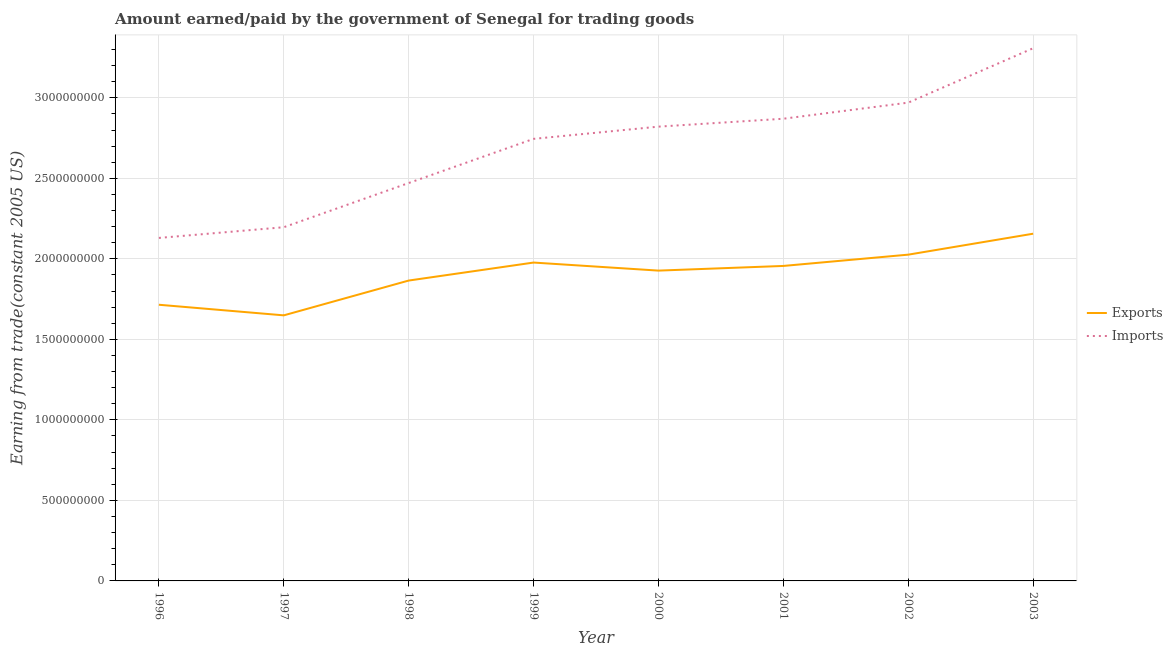Does the line corresponding to amount earned from exports intersect with the line corresponding to amount paid for imports?
Ensure brevity in your answer.  No. Is the number of lines equal to the number of legend labels?
Provide a succinct answer. Yes. What is the amount paid for imports in 1997?
Give a very brief answer. 2.20e+09. Across all years, what is the maximum amount earned from exports?
Offer a very short reply. 2.16e+09. Across all years, what is the minimum amount earned from exports?
Provide a short and direct response. 1.65e+09. In which year was the amount paid for imports maximum?
Provide a succinct answer. 2003. In which year was the amount earned from exports minimum?
Offer a very short reply. 1997. What is the total amount paid for imports in the graph?
Your answer should be compact. 2.15e+1. What is the difference between the amount earned from exports in 1998 and that in 1999?
Provide a short and direct response. -1.12e+08. What is the difference between the amount earned from exports in 2003 and the amount paid for imports in 1996?
Your response must be concise. 2.62e+07. What is the average amount paid for imports per year?
Give a very brief answer. 2.69e+09. In the year 1998, what is the difference between the amount earned from exports and amount paid for imports?
Make the answer very short. -6.06e+08. What is the ratio of the amount paid for imports in 2001 to that in 2002?
Make the answer very short. 0.97. Is the difference between the amount paid for imports in 1999 and 2003 greater than the difference between the amount earned from exports in 1999 and 2003?
Provide a succinct answer. No. What is the difference between the highest and the second highest amount paid for imports?
Offer a very short reply. 3.38e+08. What is the difference between the highest and the lowest amount earned from exports?
Ensure brevity in your answer.  5.07e+08. In how many years, is the amount paid for imports greater than the average amount paid for imports taken over all years?
Your answer should be compact. 5. Is the sum of the amount paid for imports in 1999 and 2002 greater than the maximum amount earned from exports across all years?
Make the answer very short. Yes. Does the amount paid for imports monotonically increase over the years?
Provide a short and direct response. Yes. Is the amount earned from exports strictly less than the amount paid for imports over the years?
Offer a terse response. Yes. How many lines are there?
Keep it short and to the point. 2. Does the graph contain any zero values?
Offer a terse response. No. Does the graph contain grids?
Your answer should be compact. Yes. Where does the legend appear in the graph?
Ensure brevity in your answer.  Center right. What is the title of the graph?
Provide a succinct answer. Amount earned/paid by the government of Senegal for trading goods. Does "Female labor force" appear as one of the legend labels in the graph?
Your answer should be compact. No. What is the label or title of the X-axis?
Your answer should be very brief. Year. What is the label or title of the Y-axis?
Offer a terse response. Earning from trade(constant 2005 US). What is the Earning from trade(constant 2005 US) of Exports in 1996?
Provide a succinct answer. 1.72e+09. What is the Earning from trade(constant 2005 US) of Imports in 1996?
Your response must be concise. 2.13e+09. What is the Earning from trade(constant 2005 US) in Exports in 1997?
Ensure brevity in your answer.  1.65e+09. What is the Earning from trade(constant 2005 US) of Imports in 1997?
Your answer should be compact. 2.20e+09. What is the Earning from trade(constant 2005 US) in Exports in 1998?
Provide a succinct answer. 1.87e+09. What is the Earning from trade(constant 2005 US) of Imports in 1998?
Offer a very short reply. 2.47e+09. What is the Earning from trade(constant 2005 US) of Exports in 1999?
Provide a short and direct response. 1.98e+09. What is the Earning from trade(constant 2005 US) in Imports in 1999?
Keep it short and to the point. 2.75e+09. What is the Earning from trade(constant 2005 US) of Exports in 2000?
Provide a succinct answer. 1.93e+09. What is the Earning from trade(constant 2005 US) in Imports in 2000?
Ensure brevity in your answer.  2.82e+09. What is the Earning from trade(constant 2005 US) in Exports in 2001?
Provide a short and direct response. 1.96e+09. What is the Earning from trade(constant 2005 US) of Imports in 2001?
Make the answer very short. 2.87e+09. What is the Earning from trade(constant 2005 US) in Exports in 2002?
Your answer should be very brief. 2.03e+09. What is the Earning from trade(constant 2005 US) of Imports in 2002?
Provide a short and direct response. 2.97e+09. What is the Earning from trade(constant 2005 US) in Exports in 2003?
Your response must be concise. 2.16e+09. What is the Earning from trade(constant 2005 US) of Imports in 2003?
Provide a succinct answer. 3.31e+09. Across all years, what is the maximum Earning from trade(constant 2005 US) of Exports?
Keep it short and to the point. 2.16e+09. Across all years, what is the maximum Earning from trade(constant 2005 US) in Imports?
Ensure brevity in your answer.  3.31e+09. Across all years, what is the minimum Earning from trade(constant 2005 US) in Exports?
Your answer should be compact. 1.65e+09. Across all years, what is the minimum Earning from trade(constant 2005 US) of Imports?
Make the answer very short. 2.13e+09. What is the total Earning from trade(constant 2005 US) of Exports in the graph?
Make the answer very short. 1.53e+1. What is the total Earning from trade(constant 2005 US) in Imports in the graph?
Offer a very short reply. 2.15e+1. What is the difference between the Earning from trade(constant 2005 US) of Exports in 1996 and that in 1997?
Offer a terse response. 6.59e+07. What is the difference between the Earning from trade(constant 2005 US) of Imports in 1996 and that in 1997?
Your response must be concise. -6.64e+07. What is the difference between the Earning from trade(constant 2005 US) of Exports in 1996 and that in 1998?
Make the answer very short. -1.50e+08. What is the difference between the Earning from trade(constant 2005 US) of Imports in 1996 and that in 1998?
Make the answer very short. -3.41e+08. What is the difference between the Earning from trade(constant 2005 US) of Exports in 1996 and that in 1999?
Your answer should be very brief. -2.62e+08. What is the difference between the Earning from trade(constant 2005 US) of Imports in 1996 and that in 1999?
Offer a very short reply. -6.15e+08. What is the difference between the Earning from trade(constant 2005 US) of Exports in 1996 and that in 2000?
Provide a succinct answer. -2.12e+08. What is the difference between the Earning from trade(constant 2005 US) in Imports in 1996 and that in 2000?
Your answer should be very brief. -6.91e+08. What is the difference between the Earning from trade(constant 2005 US) of Exports in 1996 and that in 2001?
Your response must be concise. -2.41e+08. What is the difference between the Earning from trade(constant 2005 US) of Imports in 1996 and that in 2001?
Offer a terse response. -7.40e+08. What is the difference between the Earning from trade(constant 2005 US) of Exports in 1996 and that in 2002?
Provide a short and direct response. -3.11e+08. What is the difference between the Earning from trade(constant 2005 US) of Imports in 1996 and that in 2002?
Ensure brevity in your answer.  -8.40e+08. What is the difference between the Earning from trade(constant 2005 US) in Exports in 1996 and that in 2003?
Your answer should be compact. -4.41e+08. What is the difference between the Earning from trade(constant 2005 US) in Imports in 1996 and that in 2003?
Your answer should be very brief. -1.18e+09. What is the difference between the Earning from trade(constant 2005 US) of Exports in 1997 and that in 1998?
Provide a short and direct response. -2.16e+08. What is the difference between the Earning from trade(constant 2005 US) in Imports in 1997 and that in 1998?
Your answer should be compact. -2.74e+08. What is the difference between the Earning from trade(constant 2005 US) of Exports in 1997 and that in 1999?
Your answer should be very brief. -3.28e+08. What is the difference between the Earning from trade(constant 2005 US) of Imports in 1997 and that in 1999?
Provide a short and direct response. -5.49e+08. What is the difference between the Earning from trade(constant 2005 US) in Exports in 1997 and that in 2000?
Your answer should be compact. -2.78e+08. What is the difference between the Earning from trade(constant 2005 US) in Imports in 1997 and that in 2000?
Ensure brevity in your answer.  -6.25e+08. What is the difference between the Earning from trade(constant 2005 US) of Exports in 1997 and that in 2001?
Make the answer very short. -3.07e+08. What is the difference between the Earning from trade(constant 2005 US) in Imports in 1997 and that in 2001?
Ensure brevity in your answer.  -6.74e+08. What is the difference between the Earning from trade(constant 2005 US) in Exports in 1997 and that in 2002?
Your answer should be compact. -3.77e+08. What is the difference between the Earning from trade(constant 2005 US) of Imports in 1997 and that in 2002?
Provide a short and direct response. -7.74e+08. What is the difference between the Earning from trade(constant 2005 US) in Exports in 1997 and that in 2003?
Keep it short and to the point. -5.07e+08. What is the difference between the Earning from trade(constant 2005 US) in Imports in 1997 and that in 2003?
Your answer should be very brief. -1.11e+09. What is the difference between the Earning from trade(constant 2005 US) of Exports in 1998 and that in 1999?
Ensure brevity in your answer.  -1.12e+08. What is the difference between the Earning from trade(constant 2005 US) of Imports in 1998 and that in 1999?
Your answer should be compact. -2.74e+08. What is the difference between the Earning from trade(constant 2005 US) of Exports in 1998 and that in 2000?
Provide a succinct answer. -6.18e+07. What is the difference between the Earning from trade(constant 2005 US) in Imports in 1998 and that in 2000?
Your answer should be very brief. -3.50e+08. What is the difference between the Earning from trade(constant 2005 US) in Exports in 1998 and that in 2001?
Your answer should be compact. -9.08e+07. What is the difference between the Earning from trade(constant 2005 US) of Imports in 1998 and that in 2001?
Your response must be concise. -3.99e+08. What is the difference between the Earning from trade(constant 2005 US) in Exports in 1998 and that in 2002?
Your response must be concise. -1.61e+08. What is the difference between the Earning from trade(constant 2005 US) in Imports in 1998 and that in 2002?
Your answer should be compact. -4.99e+08. What is the difference between the Earning from trade(constant 2005 US) in Exports in 1998 and that in 2003?
Keep it short and to the point. -2.91e+08. What is the difference between the Earning from trade(constant 2005 US) in Imports in 1998 and that in 2003?
Make the answer very short. -8.37e+08. What is the difference between the Earning from trade(constant 2005 US) of Exports in 1999 and that in 2000?
Make the answer very short. 5.00e+07. What is the difference between the Earning from trade(constant 2005 US) in Imports in 1999 and that in 2000?
Your response must be concise. -7.59e+07. What is the difference between the Earning from trade(constant 2005 US) of Exports in 1999 and that in 2001?
Your response must be concise. 2.10e+07. What is the difference between the Earning from trade(constant 2005 US) in Imports in 1999 and that in 2001?
Keep it short and to the point. -1.25e+08. What is the difference between the Earning from trade(constant 2005 US) of Exports in 1999 and that in 2002?
Ensure brevity in your answer.  -4.91e+07. What is the difference between the Earning from trade(constant 2005 US) in Imports in 1999 and that in 2002?
Offer a very short reply. -2.25e+08. What is the difference between the Earning from trade(constant 2005 US) in Exports in 1999 and that in 2003?
Your response must be concise. -1.79e+08. What is the difference between the Earning from trade(constant 2005 US) in Imports in 1999 and that in 2003?
Give a very brief answer. -5.63e+08. What is the difference between the Earning from trade(constant 2005 US) in Exports in 2000 and that in 2001?
Your response must be concise. -2.90e+07. What is the difference between the Earning from trade(constant 2005 US) in Imports in 2000 and that in 2001?
Make the answer very short. -4.91e+07. What is the difference between the Earning from trade(constant 2005 US) in Exports in 2000 and that in 2002?
Provide a short and direct response. -9.91e+07. What is the difference between the Earning from trade(constant 2005 US) in Imports in 2000 and that in 2002?
Provide a succinct answer. -1.49e+08. What is the difference between the Earning from trade(constant 2005 US) of Exports in 2000 and that in 2003?
Your response must be concise. -2.29e+08. What is the difference between the Earning from trade(constant 2005 US) of Imports in 2000 and that in 2003?
Your answer should be very brief. -4.87e+08. What is the difference between the Earning from trade(constant 2005 US) of Exports in 2001 and that in 2002?
Keep it short and to the point. -7.01e+07. What is the difference between the Earning from trade(constant 2005 US) in Imports in 2001 and that in 2002?
Provide a succinct answer. -1.00e+08. What is the difference between the Earning from trade(constant 2005 US) in Exports in 2001 and that in 2003?
Your answer should be very brief. -2.00e+08. What is the difference between the Earning from trade(constant 2005 US) in Imports in 2001 and that in 2003?
Your answer should be compact. -4.38e+08. What is the difference between the Earning from trade(constant 2005 US) in Exports in 2002 and that in 2003?
Your answer should be compact. -1.30e+08. What is the difference between the Earning from trade(constant 2005 US) of Imports in 2002 and that in 2003?
Your response must be concise. -3.38e+08. What is the difference between the Earning from trade(constant 2005 US) in Exports in 1996 and the Earning from trade(constant 2005 US) in Imports in 1997?
Give a very brief answer. -4.81e+08. What is the difference between the Earning from trade(constant 2005 US) in Exports in 1996 and the Earning from trade(constant 2005 US) in Imports in 1998?
Give a very brief answer. -7.56e+08. What is the difference between the Earning from trade(constant 2005 US) in Exports in 1996 and the Earning from trade(constant 2005 US) in Imports in 1999?
Offer a terse response. -1.03e+09. What is the difference between the Earning from trade(constant 2005 US) of Exports in 1996 and the Earning from trade(constant 2005 US) of Imports in 2000?
Give a very brief answer. -1.11e+09. What is the difference between the Earning from trade(constant 2005 US) of Exports in 1996 and the Earning from trade(constant 2005 US) of Imports in 2001?
Offer a very short reply. -1.16e+09. What is the difference between the Earning from trade(constant 2005 US) of Exports in 1996 and the Earning from trade(constant 2005 US) of Imports in 2002?
Your answer should be compact. -1.26e+09. What is the difference between the Earning from trade(constant 2005 US) in Exports in 1996 and the Earning from trade(constant 2005 US) in Imports in 2003?
Your response must be concise. -1.59e+09. What is the difference between the Earning from trade(constant 2005 US) in Exports in 1997 and the Earning from trade(constant 2005 US) in Imports in 1998?
Your answer should be very brief. -8.22e+08. What is the difference between the Earning from trade(constant 2005 US) of Exports in 1997 and the Earning from trade(constant 2005 US) of Imports in 1999?
Your response must be concise. -1.10e+09. What is the difference between the Earning from trade(constant 2005 US) in Exports in 1997 and the Earning from trade(constant 2005 US) in Imports in 2000?
Provide a short and direct response. -1.17e+09. What is the difference between the Earning from trade(constant 2005 US) of Exports in 1997 and the Earning from trade(constant 2005 US) of Imports in 2001?
Give a very brief answer. -1.22e+09. What is the difference between the Earning from trade(constant 2005 US) of Exports in 1997 and the Earning from trade(constant 2005 US) of Imports in 2002?
Offer a terse response. -1.32e+09. What is the difference between the Earning from trade(constant 2005 US) of Exports in 1997 and the Earning from trade(constant 2005 US) of Imports in 2003?
Keep it short and to the point. -1.66e+09. What is the difference between the Earning from trade(constant 2005 US) in Exports in 1998 and the Earning from trade(constant 2005 US) in Imports in 1999?
Keep it short and to the point. -8.80e+08. What is the difference between the Earning from trade(constant 2005 US) in Exports in 1998 and the Earning from trade(constant 2005 US) in Imports in 2000?
Your response must be concise. -9.56e+08. What is the difference between the Earning from trade(constant 2005 US) in Exports in 1998 and the Earning from trade(constant 2005 US) in Imports in 2001?
Ensure brevity in your answer.  -1.00e+09. What is the difference between the Earning from trade(constant 2005 US) in Exports in 1998 and the Earning from trade(constant 2005 US) in Imports in 2002?
Give a very brief answer. -1.10e+09. What is the difference between the Earning from trade(constant 2005 US) of Exports in 1998 and the Earning from trade(constant 2005 US) of Imports in 2003?
Provide a succinct answer. -1.44e+09. What is the difference between the Earning from trade(constant 2005 US) in Exports in 1999 and the Earning from trade(constant 2005 US) in Imports in 2000?
Your answer should be compact. -8.44e+08. What is the difference between the Earning from trade(constant 2005 US) in Exports in 1999 and the Earning from trade(constant 2005 US) in Imports in 2001?
Offer a terse response. -8.93e+08. What is the difference between the Earning from trade(constant 2005 US) in Exports in 1999 and the Earning from trade(constant 2005 US) in Imports in 2002?
Your response must be concise. -9.93e+08. What is the difference between the Earning from trade(constant 2005 US) in Exports in 1999 and the Earning from trade(constant 2005 US) in Imports in 2003?
Offer a very short reply. -1.33e+09. What is the difference between the Earning from trade(constant 2005 US) in Exports in 2000 and the Earning from trade(constant 2005 US) in Imports in 2001?
Make the answer very short. -9.43e+08. What is the difference between the Earning from trade(constant 2005 US) in Exports in 2000 and the Earning from trade(constant 2005 US) in Imports in 2002?
Provide a succinct answer. -1.04e+09. What is the difference between the Earning from trade(constant 2005 US) of Exports in 2000 and the Earning from trade(constant 2005 US) of Imports in 2003?
Offer a very short reply. -1.38e+09. What is the difference between the Earning from trade(constant 2005 US) of Exports in 2001 and the Earning from trade(constant 2005 US) of Imports in 2002?
Your answer should be very brief. -1.01e+09. What is the difference between the Earning from trade(constant 2005 US) of Exports in 2001 and the Earning from trade(constant 2005 US) of Imports in 2003?
Your answer should be compact. -1.35e+09. What is the difference between the Earning from trade(constant 2005 US) in Exports in 2002 and the Earning from trade(constant 2005 US) in Imports in 2003?
Make the answer very short. -1.28e+09. What is the average Earning from trade(constant 2005 US) of Exports per year?
Provide a succinct answer. 1.91e+09. What is the average Earning from trade(constant 2005 US) in Imports per year?
Your answer should be compact. 2.69e+09. In the year 1996, what is the difference between the Earning from trade(constant 2005 US) in Exports and Earning from trade(constant 2005 US) in Imports?
Give a very brief answer. -4.15e+08. In the year 1997, what is the difference between the Earning from trade(constant 2005 US) of Exports and Earning from trade(constant 2005 US) of Imports?
Provide a succinct answer. -5.47e+08. In the year 1998, what is the difference between the Earning from trade(constant 2005 US) of Exports and Earning from trade(constant 2005 US) of Imports?
Your response must be concise. -6.06e+08. In the year 1999, what is the difference between the Earning from trade(constant 2005 US) of Exports and Earning from trade(constant 2005 US) of Imports?
Offer a very short reply. -7.68e+08. In the year 2000, what is the difference between the Earning from trade(constant 2005 US) in Exports and Earning from trade(constant 2005 US) in Imports?
Your response must be concise. -8.94e+08. In the year 2001, what is the difference between the Earning from trade(constant 2005 US) of Exports and Earning from trade(constant 2005 US) of Imports?
Your answer should be very brief. -9.14e+08. In the year 2002, what is the difference between the Earning from trade(constant 2005 US) in Exports and Earning from trade(constant 2005 US) in Imports?
Offer a very short reply. -9.44e+08. In the year 2003, what is the difference between the Earning from trade(constant 2005 US) of Exports and Earning from trade(constant 2005 US) of Imports?
Your answer should be very brief. -1.15e+09. What is the ratio of the Earning from trade(constant 2005 US) in Exports in 1996 to that in 1997?
Provide a succinct answer. 1.04. What is the ratio of the Earning from trade(constant 2005 US) of Imports in 1996 to that in 1997?
Your answer should be compact. 0.97. What is the ratio of the Earning from trade(constant 2005 US) of Exports in 1996 to that in 1998?
Make the answer very short. 0.92. What is the ratio of the Earning from trade(constant 2005 US) in Imports in 1996 to that in 1998?
Your answer should be very brief. 0.86. What is the ratio of the Earning from trade(constant 2005 US) in Exports in 1996 to that in 1999?
Ensure brevity in your answer.  0.87. What is the ratio of the Earning from trade(constant 2005 US) in Imports in 1996 to that in 1999?
Make the answer very short. 0.78. What is the ratio of the Earning from trade(constant 2005 US) in Exports in 1996 to that in 2000?
Make the answer very short. 0.89. What is the ratio of the Earning from trade(constant 2005 US) in Imports in 1996 to that in 2000?
Offer a terse response. 0.76. What is the ratio of the Earning from trade(constant 2005 US) of Exports in 1996 to that in 2001?
Your response must be concise. 0.88. What is the ratio of the Earning from trade(constant 2005 US) of Imports in 1996 to that in 2001?
Provide a short and direct response. 0.74. What is the ratio of the Earning from trade(constant 2005 US) of Exports in 1996 to that in 2002?
Ensure brevity in your answer.  0.85. What is the ratio of the Earning from trade(constant 2005 US) in Imports in 1996 to that in 2002?
Keep it short and to the point. 0.72. What is the ratio of the Earning from trade(constant 2005 US) in Exports in 1996 to that in 2003?
Provide a succinct answer. 0.8. What is the ratio of the Earning from trade(constant 2005 US) of Imports in 1996 to that in 2003?
Your answer should be very brief. 0.64. What is the ratio of the Earning from trade(constant 2005 US) of Exports in 1997 to that in 1998?
Give a very brief answer. 0.88. What is the ratio of the Earning from trade(constant 2005 US) of Exports in 1997 to that in 1999?
Provide a short and direct response. 0.83. What is the ratio of the Earning from trade(constant 2005 US) in Imports in 1997 to that in 1999?
Give a very brief answer. 0.8. What is the ratio of the Earning from trade(constant 2005 US) in Exports in 1997 to that in 2000?
Your answer should be very brief. 0.86. What is the ratio of the Earning from trade(constant 2005 US) of Imports in 1997 to that in 2000?
Keep it short and to the point. 0.78. What is the ratio of the Earning from trade(constant 2005 US) in Exports in 1997 to that in 2001?
Give a very brief answer. 0.84. What is the ratio of the Earning from trade(constant 2005 US) in Imports in 1997 to that in 2001?
Ensure brevity in your answer.  0.77. What is the ratio of the Earning from trade(constant 2005 US) of Exports in 1997 to that in 2002?
Your response must be concise. 0.81. What is the ratio of the Earning from trade(constant 2005 US) in Imports in 1997 to that in 2002?
Keep it short and to the point. 0.74. What is the ratio of the Earning from trade(constant 2005 US) in Exports in 1997 to that in 2003?
Your answer should be compact. 0.76. What is the ratio of the Earning from trade(constant 2005 US) of Imports in 1997 to that in 2003?
Keep it short and to the point. 0.66. What is the ratio of the Earning from trade(constant 2005 US) in Exports in 1998 to that in 1999?
Make the answer very short. 0.94. What is the ratio of the Earning from trade(constant 2005 US) of Imports in 1998 to that in 1999?
Provide a short and direct response. 0.9. What is the ratio of the Earning from trade(constant 2005 US) of Exports in 1998 to that in 2000?
Your answer should be compact. 0.97. What is the ratio of the Earning from trade(constant 2005 US) in Imports in 1998 to that in 2000?
Make the answer very short. 0.88. What is the ratio of the Earning from trade(constant 2005 US) of Exports in 1998 to that in 2001?
Offer a very short reply. 0.95. What is the ratio of the Earning from trade(constant 2005 US) in Imports in 1998 to that in 2001?
Give a very brief answer. 0.86. What is the ratio of the Earning from trade(constant 2005 US) in Exports in 1998 to that in 2002?
Ensure brevity in your answer.  0.92. What is the ratio of the Earning from trade(constant 2005 US) of Imports in 1998 to that in 2002?
Offer a terse response. 0.83. What is the ratio of the Earning from trade(constant 2005 US) of Exports in 1998 to that in 2003?
Your answer should be compact. 0.87. What is the ratio of the Earning from trade(constant 2005 US) in Imports in 1998 to that in 2003?
Make the answer very short. 0.75. What is the ratio of the Earning from trade(constant 2005 US) of Exports in 1999 to that in 2000?
Keep it short and to the point. 1.03. What is the ratio of the Earning from trade(constant 2005 US) in Imports in 1999 to that in 2000?
Give a very brief answer. 0.97. What is the ratio of the Earning from trade(constant 2005 US) in Exports in 1999 to that in 2001?
Your answer should be very brief. 1.01. What is the ratio of the Earning from trade(constant 2005 US) in Imports in 1999 to that in 2001?
Keep it short and to the point. 0.96. What is the ratio of the Earning from trade(constant 2005 US) of Exports in 1999 to that in 2002?
Provide a short and direct response. 0.98. What is the ratio of the Earning from trade(constant 2005 US) of Imports in 1999 to that in 2002?
Provide a succinct answer. 0.92. What is the ratio of the Earning from trade(constant 2005 US) of Exports in 1999 to that in 2003?
Keep it short and to the point. 0.92. What is the ratio of the Earning from trade(constant 2005 US) of Imports in 1999 to that in 2003?
Your answer should be compact. 0.83. What is the ratio of the Earning from trade(constant 2005 US) in Exports in 2000 to that in 2001?
Ensure brevity in your answer.  0.99. What is the ratio of the Earning from trade(constant 2005 US) in Imports in 2000 to that in 2001?
Provide a succinct answer. 0.98. What is the ratio of the Earning from trade(constant 2005 US) of Exports in 2000 to that in 2002?
Provide a short and direct response. 0.95. What is the ratio of the Earning from trade(constant 2005 US) in Imports in 2000 to that in 2002?
Provide a short and direct response. 0.95. What is the ratio of the Earning from trade(constant 2005 US) of Exports in 2000 to that in 2003?
Ensure brevity in your answer.  0.89. What is the ratio of the Earning from trade(constant 2005 US) of Imports in 2000 to that in 2003?
Offer a terse response. 0.85. What is the ratio of the Earning from trade(constant 2005 US) in Exports in 2001 to that in 2002?
Make the answer very short. 0.97. What is the ratio of the Earning from trade(constant 2005 US) in Imports in 2001 to that in 2002?
Provide a succinct answer. 0.97. What is the ratio of the Earning from trade(constant 2005 US) in Exports in 2001 to that in 2003?
Your response must be concise. 0.91. What is the ratio of the Earning from trade(constant 2005 US) of Imports in 2001 to that in 2003?
Offer a terse response. 0.87. What is the ratio of the Earning from trade(constant 2005 US) of Exports in 2002 to that in 2003?
Offer a very short reply. 0.94. What is the ratio of the Earning from trade(constant 2005 US) of Imports in 2002 to that in 2003?
Your answer should be compact. 0.9. What is the difference between the highest and the second highest Earning from trade(constant 2005 US) of Exports?
Provide a short and direct response. 1.30e+08. What is the difference between the highest and the second highest Earning from trade(constant 2005 US) of Imports?
Give a very brief answer. 3.38e+08. What is the difference between the highest and the lowest Earning from trade(constant 2005 US) in Exports?
Provide a succinct answer. 5.07e+08. What is the difference between the highest and the lowest Earning from trade(constant 2005 US) of Imports?
Ensure brevity in your answer.  1.18e+09. 